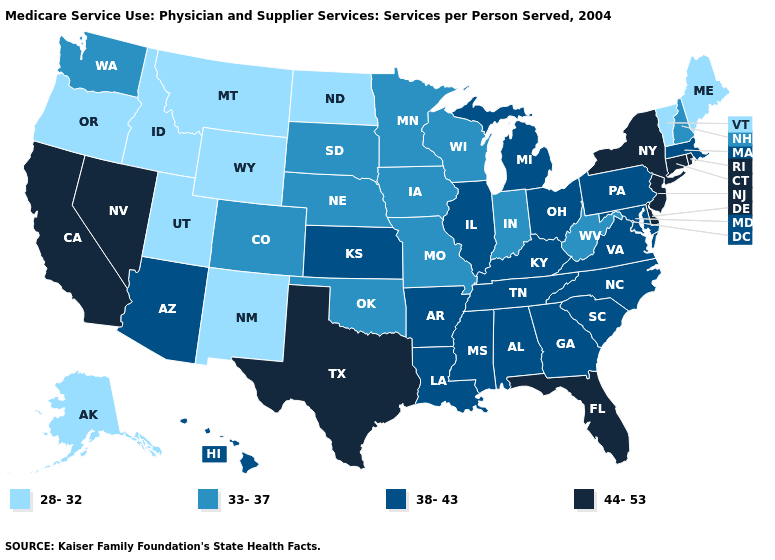Name the states that have a value in the range 38-43?
Keep it brief. Alabama, Arizona, Arkansas, Georgia, Hawaii, Illinois, Kansas, Kentucky, Louisiana, Maryland, Massachusetts, Michigan, Mississippi, North Carolina, Ohio, Pennsylvania, South Carolina, Tennessee, Virginia. Does the map have missing data?
Answer briefly. No. What is the lowest value in the MidWest?
Short answer required. 28-32. Among the states that border New Jersey , does Pennsylvania have the lowest value?
Write a very short answer. Yes. What is the value of Wyoming?
Answer briefly. 28-32. Which states have the highest value in the USA?
Concise answer only. California, Connecticut, Delaware, Florida, Nevada, New Jersey, New York, Rhode Island, Texas. Does North Dakota have the lowest value in the MidWest?
Be succinct. Yes. What is the highest value in the USA?
Write a very short answer. 44-53. What is the value of Alaska?
Be succinct. 28-32. Which states have the lowest value in the South?
Give a very brief answer. Oklahoma, West Virginia. What is the lowest value in the West?
Give a very brief answer. 28-32. What is the highest value in the USA?
Keep it brief. 44-53. What is the value of Kansas?
Answer briefly. 38-43. Name the states that have a value in the range 38-43?
Keep it brief. Alabama, Arizona, Arkansas, Georgia, Hawaii, Illinois, Kansas, Kentucky, Louisiana, Maryland, Massachusetts, Michigan, Mississippi, North Carolina, Ohio, Pennsylvania, South Carolina, Tennessee, Virginia. What is the highest value in states that border South Dakota?
Answer briefly. 33-37. 